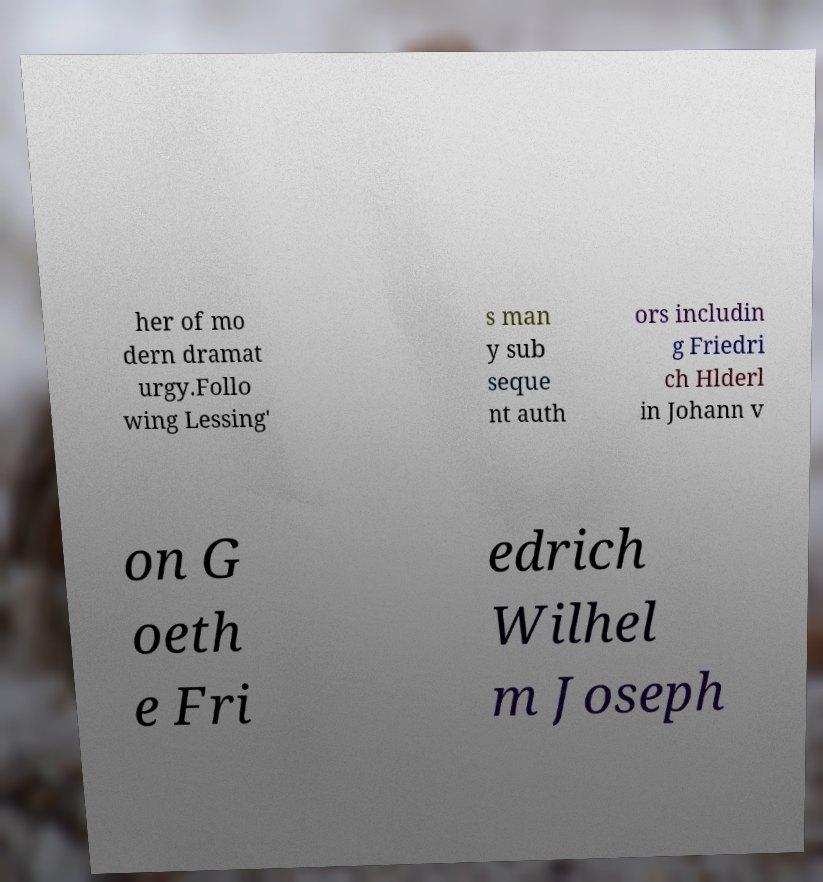Please identify and transcribe the text found in this image. her of mo dern dramat urgy.Follo wing Lessing' s man y sub seque nt auth ors includin g Friedri ch Hlderl in Johann v on G oeth e Fri edrich Wilhel m Joseph 